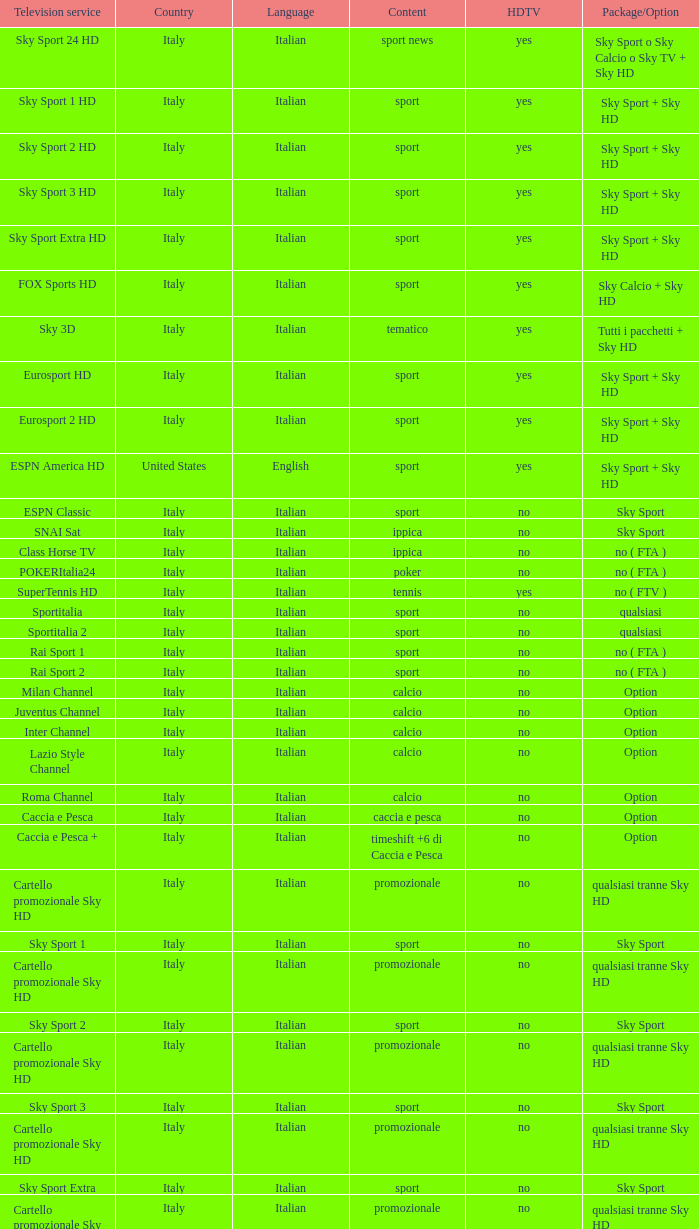What is Package/Option, when Content is Poker? No ( fta ). 